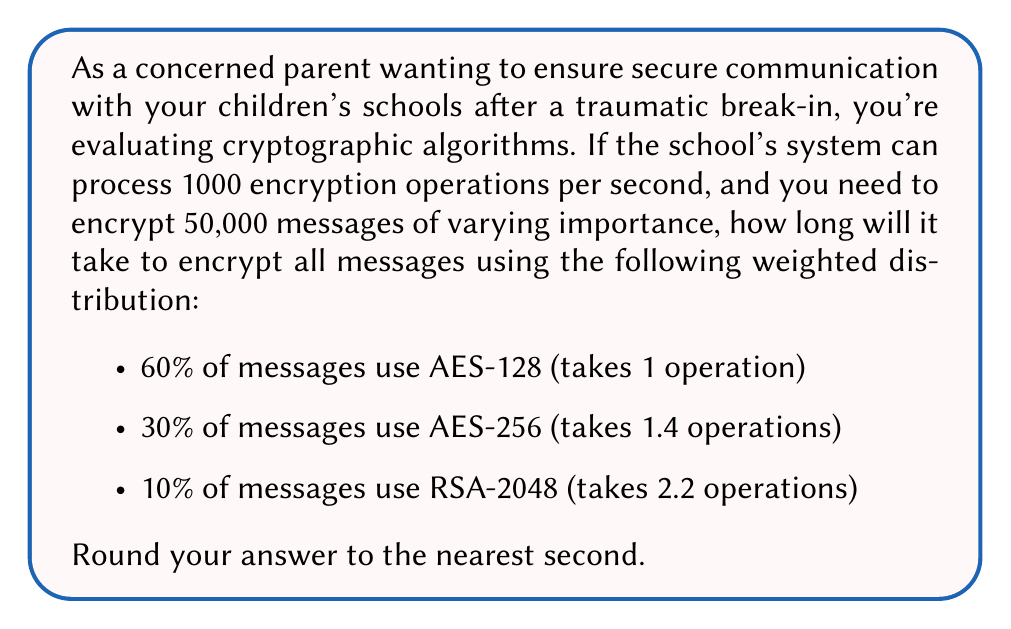Can you solve this math problem? Let's break this down step-by-step:

1) First, let's calculate the number of messages for each encryption type:
   - AES-128: $0.60 \times 50,000 = 30,000$ messages
   - AES-256: $0.30 \times 50,000 = 15,000$ messages
   - RSA-2048: $0.10 \times 50,000 = 5,000$ messages

2) Now, let's calculate the number of operations for each type:
   - AES-128: $30,000 \times 1 = 30,000$ operations
   - AES-256: $15,000 \times 1.4 = 21,000$ operations
   - RSA-2048: $5,000 \times 2.2 = 11,000$ operations

3) Total number of operations:
   $30,000 + 21,000 + 11,000 = 62,000$ operations

4) Time taken:
   $\frac{62,000 \text{ operations}}{1000 \text{ operations/second}} = 62 \text{ seconds}$

Therefore, it will take 62 seconds to encrypt all the messages.
Answer: 62 seconds 